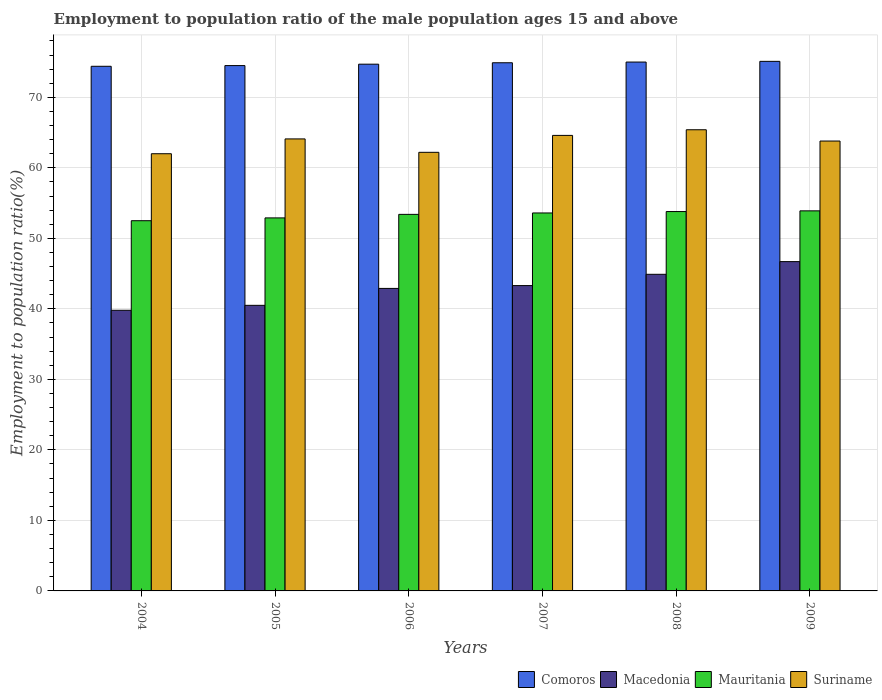How many different coloured bars are there?
Offer a terse response. 4. Are the number of bars per tick equal to the number of legend labels?
Make the answer very short. Yes. How many bars are there on the 3rd tick from the right?
Your answer should be very brief. 4. In how many cases, is the number of bars for a given year not equal to the number of legend labels?
Your answer should be compact. 0. What is the employment to population ratio in Mauritania in 2006?
Offer a very short reply. 53.4. Across all years, what is the maximum employment to population ratio in Comoros?
Your response must be concise. 75.1. Across all years, what is the minimum employment to population ratio in Suriname?
Offer a very short reply. 62. What is the total employment to population ratio in Mauritania in the graph?
Provide a short and direct response. 320.1. What is the difference between the employment to population ratio in Suriname in 2005 and that in 2009?
Keep it short and to the point. 0.3. What is the difference between the employment to population ratio in Suriname in 2009 and the employment to population ratio in Mauritania in 2004?
Offer a terse response. 11.3. What is the average employment to population ratio in Macedonia per year?
Provide a succinct answer. 43.02. In the year 2009, what is the difference between the employment to population ratio in Macedonia and employment to population ratio in Suriname?
Keep it short and to the point. -17.1. In how many years, is the employment to population ratio in Suriname greater than 36 %?
Offer a terse response. 6. What is the ratio of the employment to population ratio in Comoros in 2004 to that in 2006?
Your answer should be compact. 1. What is the difference between the highest and the second highest employment to population ratio in Macedonia?
Your response must be concise. 1.8. What is the difference between the highest and the lowest employment to population ratio in Suriname?
Offer a very short reply. 3.4. Is it the case that in every year, the sum of the employment to population ratio in Macedonia and employment to population ratio in Mauritania is greater than the sum of employment to population ratio in Comoros and employment to population ratio in Suriname?
Make the answer very short. No. What does the 4th bar from the left in 2007 represents?
Make the answer very short. Suriname. What does the 4th bar from the right in 2008 represents?
Your answer should be compact. Comoros. How many bars are there?
Keep it short and to the point. 24. Are all the bars in the graph horizontal?
Your response must be concise. No. How many years are there in the graph?
Your answer should be very brief. 6. What is the difference between two consecutive major ticks on the Y-axis?
Give a very brief answer. 10. Where does the legend appear in the graph?
Keep it short and to the point. Bottom right. How many legend labels are there?
Make the answer very short. 4. What is the title of the graph?
Provide a short and direct response. Employment to population ratio of the male population ages 15 and above. What is the label or title of the X-axis?
Your answer should be compact. Years. What is the Employment to population ratio(%) of Comoros in 2004?
Your answer should be very brief. 74.4. What is the Employment to population ratio(%) in Macedonia in 2004?
Make the answer very short. 39.8. What is the Employment to population ratio(%) in Mauritania in 2004?
Keep it short and to the point. 52.5. What is the Employment to population ratio(%) in Comoros in 2005?
Provide a short and direct response. 74.5. What is the Employment to population ratio(%) in Macedonia in 2005?
Offer a very short reply. 40.5. What is the Employment to population ratio(%) in Mauritania in 2005?
Your answer should be compact. 52.9. What is the Employment to population ratio(%) of Suriname in 2005?
Offer a terse response. 64.1. What is the Employment to population ratio(%) of Comoros in 2006?
Provide a short and direct response. 74.7. What is the Employment to population ratio(%) in Macedonia in 2006?
Your response must be concise. 42.9. What is the Employment to population ratio(%) in Mauritania in 2006?
Your answer should be very brief. 53.4. What is the Employment to population ratio(%) of Suriname in 2006?
Provide a succinct answer. 62.2. What is the Employment to population ratio(%) in Comoros in 2007?
Offer a terse response. 74.9. What is the Employment to population ratio(%) in Macedonia in 2007?
Offer a very short reply. 43.3. What is the Employment to population ratio(%) of Mauritania in 2007?
Provide a succinct answer. 53.6. What is the Employment to population ratio(%) of Suriname in 2007?
Your answer should be compact. 64.6. What is the Employment to population ratio(%) in Comoros in 2008?
Your answer should be compact. 75. What is the Employment to population ratio(%) in Macedonia in 2008?
Ensure brevity in your answer.  44.9. What is the Employment to population ratio(%) of Mauritania in 2008?
Offer a terse response. 53.8. What is the Employment to population ratio(%) in Suriname in 2008?
Keep it short and to the point. 65.4. What is the Employment to population ratio(%) in Comoros in 2009?
Provide a short and direct response. 75.1. What is the Employment to population ratio(%) in Macedonia in 2009?
Provide a short and direct response. 46.7. What is the Employment to population ratio(%) in Mauritania in 2009?
Make the answer very short. 53.9. What is the Employment to population ratio(%) of Suriname in 2009?
Give a very brief answer. 63.8. Across all years, what is the maximum Employment to population ratio(%) in Comoros?
Provide a short and direct response. 75.1. Across all years, what is the maximum Employment to population ratio(%) in Macedonia?
Offer a terse response. 46.7. Across all years, what is the maximum Employment to population ratio(%) in Mauritania?
Offer a terse response. 53.9. Across all years, what is the maximum Employment to population ratio(%) of Suriname?
Ensure brevity in your answer.  65.4. Across all years, what is the minimum Employment to population ratio(%) in Comoros?
Your answer should be compact. 74.4. Across all years, what is the minimum Employment to population ratio(%) in Macedonia?
Provide a succinct answer. 39.8. Across all years, what is the minimum Employment to population ratio(%) of Mauritania?
Offer a terse response. 52.5. Across all years, what is the minimum Employment to population ratio(%) of Suriname?
Offer a terse response. 62. What is the total Employment to population ratio(%) in Comoros in the graph?
Keep it short and to the point. 448.6. What is the total Employment to population ratio(%) in Macedonia in the graph?
Keep it short and to the point. 258.1. What is the total Employment to population ratio(%) of Mauritania in the graph?
Provide a succinct answer. 320.1. What is the total Employment to population ratio(%) of Suriname in the graph?
Make the answer very short. 382.1. What is the difference between the Employment to population ratio(%) of Macedonia in 2004 and that in 2005?
Your answer should be compact. -0.7. What is the difference between the Employment to population ratio(%) in Suriname in 2004 and that in 2005?
Make the answer very short. -2.1. What is the difference between the Employment to population ratio(%) of Comoros in 2004 and that in 2006?
Your answer should be compact. -0.3. What is the difference between the Employment to population ratio(%) of Mauritania in 2004 and that in 2006?
Provide a short and direct response. -0.9. What is the difference between the Employment to population ratio(%) in Suriname in 2004 and that in 2006?
Ensure brevity in your answer.  -0.2. What is the difference between the Employment to population ratio(%) in Mauritania in 2004 and that in 2007?
Ensure brevity in your answer.  -1.1. What is the difference between the Employment to population ratio(%) of Suriname in 2004 and that in 2007?
Keep it short and to the point. -2.6. What is the difference between the Employment to population ratio(%) in Mauritania in 2004 and that in 2008?
Offer a terse response. -1.3. What is the difference between the Employment to population ratio(%) in Suriname in 2004 and that in 2008?
Keep it short and to the point. -3.4. What is the difference between the Employment to population ratio(%) in Comoros in 2005 and that in 2006?
Ensure brevity in your answer.  -0.2. What is the difference between the Employment to population ratio(%) of Mauritania in 2005 and that in 2007?
Keep it short and to the point. -0.7. What is the difference between the Employment to population ratio(%) of Suriname in 2005 and that in 2007?
Ensure brevity in your answer.  -0.5. What is the difference between the Employment to population ratio(%) in Mauritania in 2005 and that in 2008?
Keep it short and to the point. -0.9. What is the difference between the Employment to population ratio(%) of Suriname in 2005 and that in 2008?
Offer a very short reply. -1.3. What is the difference between the Employment to population ratio(%) of Comoros in 2005 and that in 2009?
Provide a short and direct response. -0.6. What is the difference between the Employment to population ratio(%) in Mauritania in 2005 and that in 2009?
Your answer should be compact. -1. What is the difference between the Employment to population ratio(%) of Suriname in 2005 and that in 2009?
Give a very brief answer. 0.3. What is the difference between the Employment to population ratio(%) of Comoros in 2006 and that in 2007?
Your answer should be very brief. -0.2. What is the difference between the Employment to population ratio(%) in Macedonia in 2006 and that in 2007?
Give a very brief answer. -0.4. What is the difference between the Employment to population ratio(%) of Mauritania in 2006 and that in 2007?
Ensure brevity in your answer.  -0.2. What is the difference between the Employment to population ratio(%) of Suriname in 2006 and that in 2007?
Offer a very short reply. -2.4. What is the difference between the Employment to population ratio(%) in Macedonia in 2006 and that in 2009?
Offer a very short reply. -3.8. What is the difference between the Employment to population ratio(%) in Mauritania in 2006 and that in 2009?
Offer a very short reply. -0.5. What is the difference between the Employment to population ratio(%) of Suriname in 2006 and that in 2009?
Ensure brevity in your answer.  -1.6. What is the difference between the Employment to population ratio(%) in Macedonia in 2007 and that in 2008?
Provide a short and direct response. -1.6. What is the difference between the Employment to population ratio(%) in Mauritania in 2008 and that in 2009?
Offer a terse response. -0.1. What is the difference between the Employment to population ratio(%) in Suriname in 2008 and that in 2009?
Give a very brief answer. 1.6. What is the difference between the Employment to population ratio(%) in Comoros in 2004 and the Employment to population ratio(%) in Macedonia in 2005?
Offer a terse response. 33.9. What is the difference between the Employment to population ratio(%) in Macedonia in 2004 and the Employment to population ratio(%) in Mauritania in 2005?
Provide a succinct answer. -13.1. What is the difference between the Employment to population ratio(%) of Macedonia in 2004 and the Employment to population ratio(%) of Suriname in 2005?
Your answer should be compact. -24.3. What is the difference between the Employment to population ratio(%) of Comoros in 2004 and the Employment to population ratio(%) of Macedonia in 2006?
Your response must be concise. 31.5. What is the difference between the Employment to population ratio(%) in Comoros in 2004 and the Employment to population ratio(%) in Mauritania in 2006?
Your answer should be very brief. 21. What is the difference between the Employment to population ratio(%) of Macedonia in 2004 and the Employment to population ratio(%) of Suriname in 2006?
Make the answer very short. -22.4. What is the difference between the Employment to population ratio(%) of Mauritania in 2004 and the Employment to population ratio(%) of Suriname in 2006?
Make the answer very short. -9.7. What is the difference between the Employment to population ratio(%) in Comoros in 2004 and the Employment to population ratio(%) in Macedonia in 2007?
Give a very brief answer. 31.1. What is the difference between the Employment to population ratio(%) in Comoros in 2004 and the Employment to population ratio(%) in Mauritania in 2007?
Keep it short and to the point. 20.8. What is the difference between the Employment to population ratio(%) of Comoros in 2004 and the Employment to population ratio(%) of Suriname in 2007?
Provide a succinct answer. 9.8. What is the difference between the Employment to population ratio(%) of Macedonia in 2004 and the Employment to population ratio(%) of Mauritania in 2007?
Give a very brief answer. -13.8. What is the difference between the Employment to population ratio(%) in Macedonia in 2004 and the Employment to population ratio(%) in Suriname in 2007?
Offer a very short reply. -24.8. What is the difference between the Employment to population ratio(%) of Mauritania in 2004 and the Employment to population ratio(%) of Suriname in 2007?
Offer a terse response. -12.1. What is the difference between the Employment to population ratio(%) in Comoros in 2004 and the Employment to population ratio(%) in Macedonia in 2008?
Keep it short and to the point. 29.5. What is the difference between the Employment to population ratio(%) in Comoros in 2004 and the Employment to population ratio(%) in Mauritania in 2008?
Your response must be concise. 20.6. What is the difference between the Employment to population ratio(%) in Comoros in 2004 and the Employment to population ratio(%) in Suriname in 2008?
Give a very brief answer. 9. What is the difference between the Employment to population ratio(%) in Macedonia in 2004 and the Employment to population ratio(%) in Mauritania in 2008?
Make the answer very short. -14. What is the difference between the Employment to population ratio(%) in Macedonia in 2004 and the Employment to population ratio(%) in Suriname in 2008?
Keep it short and to the point. -25.6. What is the difference between the Employment to population ratio(%) of Mauritania in 2004 and the Employment to population ratio(%) of Suriname in 2008?
Your answer should be very brief. -12.9. What is the difference between the Employment to population ratio(%) in Comoros in 2004 and the Employment to population ratio(%) in Macedonia in 2009?
Give a very brief answer. 27.7. What is the difference between the Employment to population ratio(%) in Comoros in 2004 and the Employment to population ratio(%) in Mauritania in 2009?
Offer a very short reply. 20.5. What is the difference between the Employment to population ratio(%) in Macedonia in 2004 and the Employment to population ratio(%) in Mauritania in 2009?
Your answer should be compact. -14.1. What is the difference between the Employment to population ratio(%) of Comoros in 2005 and the Employment to population ratio(%) of Macedonia in 2006?
Make the answer very short. 31.6. What is the difference between the Employment to population ratio(%) of Comoros in 2005 and the Employment to population ratio(%) of Mauritania in 2006?
Provide a short and direct response. 21.1. What is the difference between the Employment to population ratio(%) in Macedonia in 2005 and the Employment to population ratio(%) in Mauritania in 2006?
Offer a very short reply. -12.9. What is the difference between the Employment to population ratio(%) of Macedonia in 2005 and the Employment to population ratio(%) of Suriname in 2006?
Your response must be concise. -21.7. What is the difference between the Employment to population ratio(%) of Comoros in 2005 and the Employment to population ratio(%) of Macedonia in 2007?
Ensure brevity in your answer.  31.2. What is the difference between the Employment to population ratio(%) in Comoros in 2005 and the Employment to population ratio(%) in Mauritania in 2007?
Keep it short and to the point. 20.9. What is the difference between the Employment to population ratio(%) in Macedonia in 2005 and the Employment to population ratio(%) in Suriname in 2007?
Offer a terse response. -24.1. What is the difference between the Employment to population ratio(%) of Mauritania in 2005 and the Employment to population ratio(%) of Suriname in 2007?
Your answer should be very brief. -11.7. What is the difference between the Employment to population ratio(%) in Comoros in 2005 and the Employment to population ratio(%) in Macedonia in 2008?
Make the answer very short. 29.6. What is the difference between the Employment to population ratio(%) in Comoros in 2005 and the Employment to population ratio(%) in Mauritania in 2008?
Make the answer very short. 20.7. What is the difference between the Employment to population ratio(%) of Macedonia in 2005 and the Employment to population ratio(%) of Suriname in 2008?
Offer a very short reply. -24.9. What is the difference between the Employment to population ratio(%) in Mauritania in 2005 and the Employment to population ratio(%) in Suriname in 2008?
Your answer should be very brief. -12.5. What is the difference between the Employment to population ratio(%) of Comoros in 2005 and the Employment to population ratio(%) of Macedonia in 2009?
Your response must be concise. 27.8. What is the difference between the Employment to population ratio(%) in Comoros in 2005 and the Employment to population ratio(%) in Mauritania in 2009?
Offer a terse response. 20.6. What is the difference between the Employment to population ratio(%) in Comoros in 2005 and the Employment to population ratio(%) in Suriname in 2009?
Keep it short and to the point. 10.7. What is the difference between the Employment to population ratio(%) in Macedonia in 2005 and the Employment to population ratio(%) in Mauritania in 2009?
Provide a succinct answer. -13.4. What is the difference between the Employment to population ratio(%) in Macedonia in 2005 and the Employment to population ratio(%) in Suriname in 2009?
Offer a very short reply. -23.3. What is the difference between the Employment to population ratio(%) of Comoros in 2006 and the Employment to population ratio(%) of Macedonia in 2007?
Your answer should be very brief. 31.4. What is the difference between the Employment to population ratio(%) in Comoros in 2006 and the Employment to population ratio(%) in Mauritania in 2007?
Keep it short and to the point. 21.1. What is the difference between the Employment to population ratio(%) of Comoros in 2006 and the Employment to population ratio(%) of Suriname in 2007?
Your answer should be compact. 10.1. What is the difference between the Employment to population ratio(%) of Macedonia in 2006 and the Employment to population ratio(%) of Suriname in 2007?
Your answer should be very brief. -21.7. What is the difference between the Employment to population ratio(%) of Comoros in 2006 and the Employment to population ratio(%) of Macedonia in 2008?
Offer a terse response. 29.8. What is the difference between the Employment to population ratio(%) in Comoros in 2006 and the Employment to population ratio(%) in Mauritania in 2008?
Offer a terse response. 20.9. What is the difference between the Employment to population ratio(%) in Comoros in 2006 and the Employment to population ratio(%) in Suriname in 2008?
Give a very brief answer. 9.3. What is the difference between the Employment to population ratio(%) in Macedonia in 2006 and the Employment to population ratio(%) in Suriname in 2008?
Your response must be concise. -22.5. What is the difference between the Employment to population ratio(%) in Comoros in 2006 and the Employment to population ratio(%) in Macedonia in 2009?
Offer a terse response. 28. What is the difference between the Employment to population ratio(%) of Comoros in 2006 and the Employment to population ratio(%) of Mauritania in 2009?
Keep it short and to the point. 20.8. What is the difference between the Employment to population ratio(%) of Comoros in 2006 and the Employment to population ratio(%) of Suriname in 2009?
Your answer should be compact. 10.9. What is the difference between the Employment to population ratio(%) in Macedonia in 2006 and the Employment to population ratio(%) in Suriname in 2009?
Ensure brevity in your answer.  -20.9. What is the difference between the Employment to population ratio(%) in Comoros in 2007 and the Employment to population ratio(%) in Mauritania in 2008?
Give a very brief answer. 21.1. What is the difference between the Employment to population ratio(%) in Comoros in 2007 and the Employment to population ratio(%) in Suriname in 2008?
Provide a short and direct response. 9.5. What is the difference between the Employment to population ratio(%) in Macedonia in 2007 and the Employment to population ratio(%) in Suriname in 2008?
Make the answer very short. -22.1. What is the difference between the Employment to population ratio(%) of Comoros in 2007 and the Employment to population ratio(%) of Macedonia in 2009?
Provide a short and direct response. 28.2. What is the difference between the Employment to population ratio(%) in Comoros in 2007 and the Employment to population ratio(%) in Mauritania in 2009?
Make the answer very short. 21. What is the difference between the Employment to population ratio(%) in Comoros in 2007 and the Employment to population ratio(%) in Suriname in 2009?
Ensure brevity in your answer.  11.1. What is the difference between the Employment to population ratio(%) in Macedonia in 2007 and the Employment to population ratio(%) in Suriname in 2009?
Your response must be concise. -20.5. What is the difference between the Employment to population ratio(%) in Mauritania in 2007 and the Employment to population ratio(%) in Suriname in 2009?
Keep it short and to the point. -10.2. What is the difference between the Employment to population ratio(%) of Comoros in 2008 and the Employment to population ratio(%) of Macedonia in 2009?
Ensure brevity in your answer.  28.3. What is the difference between the Employment to population ratio(%) in Comoros in 2008 and the Employment to population ratio(%) in Mauritania in 2009?
Keep it short and to the point. 21.1. What is the difference between the Employment to population ratio(%) of Macedonia in 2008 and the Employment to population ratio(%) of Suriname in 2009?
Your answer should be compact. -18.9. What is the average Employment to population ratio(%) in Comoros per year?
Give a very brief answer. 74.77. What is the average Employment to population ratio(%) in Macedonia per year?
Keep it short and to the point. 43.02. What is the average Employment to population ratio(%) of Mauritania per year?
Give a very brief answer. 53.35. What is the average Employment to population ratio(%) of Suriname per year?
Keep it short and to the point. 63.68. In the year 2004, what is the difference between the Employment to population ratio(%) of Comoros and Employment to population ratio(%) of Macedonia?
Offer a very short reply. 34.6. In the year 2004, what is the difference between the Employment to population ratio(%) in Comoros and Employment to population ratio(%) in Mauritania?
Make the answer very short. 21.9. In the year 2004, what is the difference between the Employment to population ratio(%) of Comoros and Employment to population ratio(%) of Suriname?
Your response must be concise. 12.4. In the year 2004, what is the difference between the Employment to population ratio(%) in Macedonia and Employment to population ratio(%) in Suriname?
Provide a short and direct response. -22.2. In the year 2005, what is the difference between the Employment to population ratio(%) in Comoros and Employment to population ratio(%) in Macedonia?
Your answer should be very brief. 34. In the year 2005, what is the difference between the Employment to population ratio(%) in Comoros and Employment to population ratio(%) in Mauritania?
Give a very brief answer. 21.6. In the year 2005, what is the difference between the Employment to population ratio(%) in Comoros and Employment to population ratio(%) in Suriname?
Provide a succinct answer. 10.4. In the year 2005, what is the difference between the Employment to population ratio(%) in Macedonia and Employment to population ratio(%) in Suriname?
Keep it short and to the point. -23.6. In the year 2005, what is the difference between the Employment to population ratio(%) of Mauritania and Employment to population ratio(%) of Suriname?
Make the answer very short. -11.2. In the year 2006, what is the difference between the Employment to population ratio(%) of Comoros and Employment to population ratio(%) of Macedonia?
Your answer should be compact. 31.8. In the year 2006, what is the difference between the Employment to population ratio(%) in Comoros and Employment to population ratio(%) in Mauritania?
Offer a very short reply. 21.3. In the year 2006, what is the difference between the Employment to population ratio(%) in Macedonia and Employment to population ratio(%) in Suriname?
Your answer should be compact. -19.3. In the year 2006, what is the difference between the Employment to population ratio(%) of Mauritania and Employment to population ratio(%) of Suriname?
Provide a succinct answer. -8.8. In the year 2007, what is the difference between the Employment to population ratio(%) of Comoros and Employment to population ratio(%) of Macedonia?
Give a very brief answer. 31.6. In the year 2007, what is the difference between the Employment to population ratio(%) in Comoros and Employment to population ratio(%) in Mauritania?
Provide a short and direct response. 21.3. In the year 2007, what is the difference between the Employment to population ratio(%) of Comoros and Employment to population ratio(%) of Suriname?
Your response must be concise. 10.3. In the year 2007, what is the difference between the Employment to population ratio(%) of Macedonia and Employment to population ratio(%) of Mauritania?
Your answer should be compact. -10.3. In the year 2007, what is the difference between the Employment to population ratio(%) in Macedonia and Employment to population ratio(%) in Suriname?
Offer a terse response. -21.3. In the year 2007, what is the difference between the Employment to population ratio(%) of Mauritania and Employment to population ratio(%) of Suriname?
Keep it short and to the point. -11. In the year 2008, what is the difference between the Employment to population ratio(%) in Comoros and Employment to population ratio(%) in Macedonia?
Your answer should be very brief. 30.1. In the year 2008, what is the difference between the Employment to population ratio(%) of Comoros and Employment to population ratio(%) of Mauritania?
Give a very brief answer. 21.2. In the year 2008, what is the difference between the Employment to population ratio(%) of Macedonia and Employment to population ratio(%) of Mauritania?
Keep it short and to the point. -8.9. In the year 2008, what is the difference between the Employment to population ratio(%) in Macedonia and Employment to population ratio(%) in Suriname?
Make the answer very short. -20.5. In the year 2009, what is the difference between the Employment to population ratio(%) of Comoros and Employment to population ratio(%) of Macedonia?
Offer a very short reply. 28.4. In the year 2009, what is the difference between the Employment to population ratio(%) of Comoros and Employment to population ratio(%) of Mauritania?
Provide a succinct answer. 21.2. In the year 2009, what is the difference between the Employment to population ratio(%) in Comoros and Employment to population ratio(%) in Suriname?
Your answer should be very brief. 11.3. In the year 2009, what is the difference between the Employment to population ratio(%) in Macedonia and Employment to population ratio(%) in Mauritania?
Your answer should be very brief. -7.2. In the year 2009, what is the difference between the Employment to population ratio(%) in Macedonia and Employment to population ratio(%) in Suriname?
Provide a short and direct response. -17.1. In the year 2009, what is the difference between the Employment to population ratio(%) in Mauritania and Employment to population ratio(%) in Suriname?
Keep it short and to the point. -9.9. What is the ratio of the Employment to population ratio(%) of Macedonia in 2004 to that in 2005?
Provide a succinct answer. 0.98. What is the ratio of the Employment to population ratio(%) in Mauritania in 2004 to that in 2005?
Your response must be concise. 0.99. What is the ratio of the Employment to population ratio(%) in Suriname in 2004 to that in 2005?
Make the answer very short. 0.97. What is the ratio of the Employment to population ratio(%) of Comoros in 2004 to that in 2006?
Offer a terse response. 1. What is the ratio of the Employment to population ratio(%) of Macedonia in 2004 to that in 2006?
Your answer should be very brief. 0.93. What is the ratio of the Employment to population ratio(%) in Mauritania in 2004 to that in 2006?
Offer a terse response. 0.98. What is the ratio of the Employment to population ratio(%) of Suriname in 2004 to that in 2006?
Give a very brief answer. 1. What is the ratio of the Employment to population ratio(%) in Macedonia in 2004 to that in 2007?
Your answer should be compact. 0.92. What is the ratio of the Employment to population ratio(%) in Mauritania in 2004 to that in 2007?
Give a very brief answer. 0.98. What is the ratio of the Employment to population ratio(%) of Suriname in 2004 to that in 2007?
Your answer should be very brief. 0.96. What is the ratio of the Employment to population ratio(%) of Macedonia in 2004 to that in 2008?
Your answer should be compact. 0.89. What is the ratio of the Employment to population ratio(%) of Mauritania in 2004 to that in 2008?
Provide a short and direct response. 0.98. What is the ratio of the Employment to population ratio(%) of Suriname in 2004 to that in 2008?
Your answer should be very brief. 0.95. What is the ratio of the Employment to population ratio(%) in Comoros in 2004 to that in 2009?
Give a very brief answer. 0.99. What is the ratio of the Employment to population ratio(%) of Macedonia in 2004 to that in 2009?
Your response must be concise. 0.85. What is the ratio of the Employment to population ratio(%) in Mauritania in 2004 to that in 2009?
Make the answer very short. 0.97. What is the ratio of the Employment to population ratio(%) of Suriname in 2004 to that in 2009?
Keep it short and to the point. 0.97. What is the ratio of the Employment to population ratio(%) in Comoros in 2005 to that in 2006?
Offer a terse response. 1. What is the ratio of the Employment to population ratio(%) in Macedonia in 2005 to that in 2006?
Keep it short and to the point. 0.94. What is the ratio of the Employment to population ratio(%) of Mauritania in 2005 to that in 2006?
Make the answer very short. 0.99. What is the ratio of the Employment to population ratio(%) of Suriname in 2005 to that in 2006?
Keep it short and to the point. 1.03. What is the ratio of the Employment to population ratio(%) in Comoros in 2005 to that in 2007?
Provide a succinct answer. 0.99. What is the ratio of the Employment to population ratio(%) of Macedonia in 2005 to that in 2007?
Offer a terse response. 0.94. What is the ratio of the Employment to population ratio(%) in Mauritania in 2005 to that in 2007?
Give a very brief answer. 0.99. What is the ratio of the Employment to population ratio(%) of Macedonia in 2005 to that in 2008?
Ensure brevity in your answer.  0.9. What is the ratio of the Employment to population ratio(%) of Mauritania in 2005 to that in 2008?
Offer a terse response. 0.98. What is the ratio of the Employment to population ratio(%) of Suriname in 2005 to that in 2008?
Offer a terse response. 0.98. What is the ratio of the Employment to population ratio(%) in Comoros in 2005 to that in 2009?
Ensure brevity in your answer.  0.99. What is the ratio of the Employment to population ratio(%) of Macedonia in 2005 to that in 2009?
Offer a terse response. 0.87. What is the ratio of the Employment to population ratio(%) of Mauritania in 2005 to that in 2009?
Give a very brief answer. 0.98. What is the ratio of the Employment to population ratio(%) of Suriname in 2005 to that in 2009?
Provide a short and direct response. 1. What is the ratio of the Employment to population ratio(%) in Comoros in 2006 to that in 2007?
Your answer should be compact. 1. What is the ratio of the Employment to population ratio(%) in Mauritania in 2006 to that in 2007?
Give a very brief answer. 1. What is the ratio of the Employment to population ratio(%) of Suriname in 2006 to that in 2007?
Offer a very short reply. 0.96. What is the ratio of the Employment to population ratio(%) in Comoros in 2006 to that in 2008?
Make the answer very short. 1. What is the ratio of the Employment to population ratio(%) of Macedonia in 2006 to that in 2008?
Provide a short and direct response. 0.96. What is the ratio of the Employment to population ratio(%) in Suriname in 2006 to that in 2008?
Ensure brevity in your answer.  0.95. What is the ratio of the Employment to population ratio(%) in Comoros in 2006 to that in 2009?
Your answer should be very brief. 0.99. What is the ratio of the Employment to population ratio(%) of Macedonia in 2006 to that in 2009?
Make the answer very short. 0.92. What is the ratio of the Employment to population ratio(%) in Mauritania in 2006 to that in 2009?
Provide a short and direct response. 0.99. What is the ratio of the Employment to population ratio(%) of Suriname in 2006 to that in 2009?
Offer a terse response. 0.97. What is the ratio of the Employment to population ratio(%) of Macedonia in 2007 to that in 2008?
Provide a succinct answer. 0.96. What is the ratio of the Employment to population ratio(%) in Mauritania in 2007 to that in 2008?
Provide a succinct answer. 1. What is the ratio of the Employment to population ratio(%) in Suriname in 2007 to that in 2008?
Your answer should be compact. 0.99. What is the ratio of the Employment to population ratio(%) in Macedonia in 2007 to that in 2009?
Keep it short and to the point. 0.93. What is the ratio of the Employment to population ratio(%) of Mauritania in 2007 to that in 2009?
Offer a terse response. 0.99. What is the ratio of the Employment to population ratio(%) in Suriname in 2007 to that in 2009?
Your response must be concise. 1.01. What is the ratio of the Employment to population ratio(%) in Comoros in 2008 to that in 2009?
Your answer should be very brief. 1. What is the ratio of the Employment to population ratio(%) of Macedonia in 2008 to that in 2009?
Provide a short and direct response. 0.96. What is the ratio of the Employment to population ratio(%) in Suriname in 2008 to that in 2009?
Make the answer very short. 1.03. What is the difference between the highest and the second highest Employment to population ratio(%) of Comoros?
Ensure brevity in your answer.  0.1. What is the difference between the highest and the second highest Employment to population ratio(%) of Macedonia?
Ensure brevity in your answer.  1.8. What is the difference between the highest and the second highest Employment to population ratio(%) of Mauritania?
Ensure brevity in your answer.  0.1. What is the difference between the highest and the second highest Employment to population ratio(%) of Suriname?
Your answer should be compact. 0.8. What is the difference between the highest and the lowest Employment to population ratio(%) in Comoros?
Your response must be concise. 0.7. What is the difference between the highest and the lowest Employment to population ratio(%) of Macedonia?
Provide a succinct answer. 6.9. 